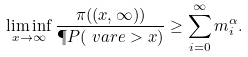Convert formula to latex. <formula><loc_0><loc_0><loc_500><loc_500>\liminf _ { x \to \infty } \frac { \pi ( ( x , \infty ) ) } { \P P ( \ v a r e > x ) } \geq \sum _ { i = 0 } ^ { \infty } m _ { i } ^ { \alpha } .</formula> 